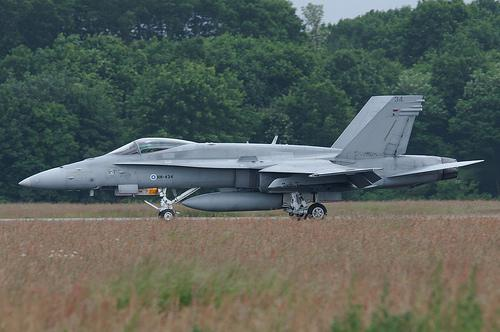Question: what type of machine is this?
Choices:
A. Lawn equipment.
B. Car.
C. Aircraft.
D. Electronic.
Answer with the letter. Answer: C Question: what color is the aircraft?
Choices:
A. White.
B. Black.
C. Silver.
D. Gray.
Answer with the letter. Answer: D Question: how many wheels can be seen?
Choices:
A. Two.
B. One.
C. Three.
D. Four.
Answer with the letter. Answer: A Question: where is this location?
Choices:
A. Aircraft runway.
B. Beach.
C. Africa.
D. South.
Answer with the letter. Answer: A 